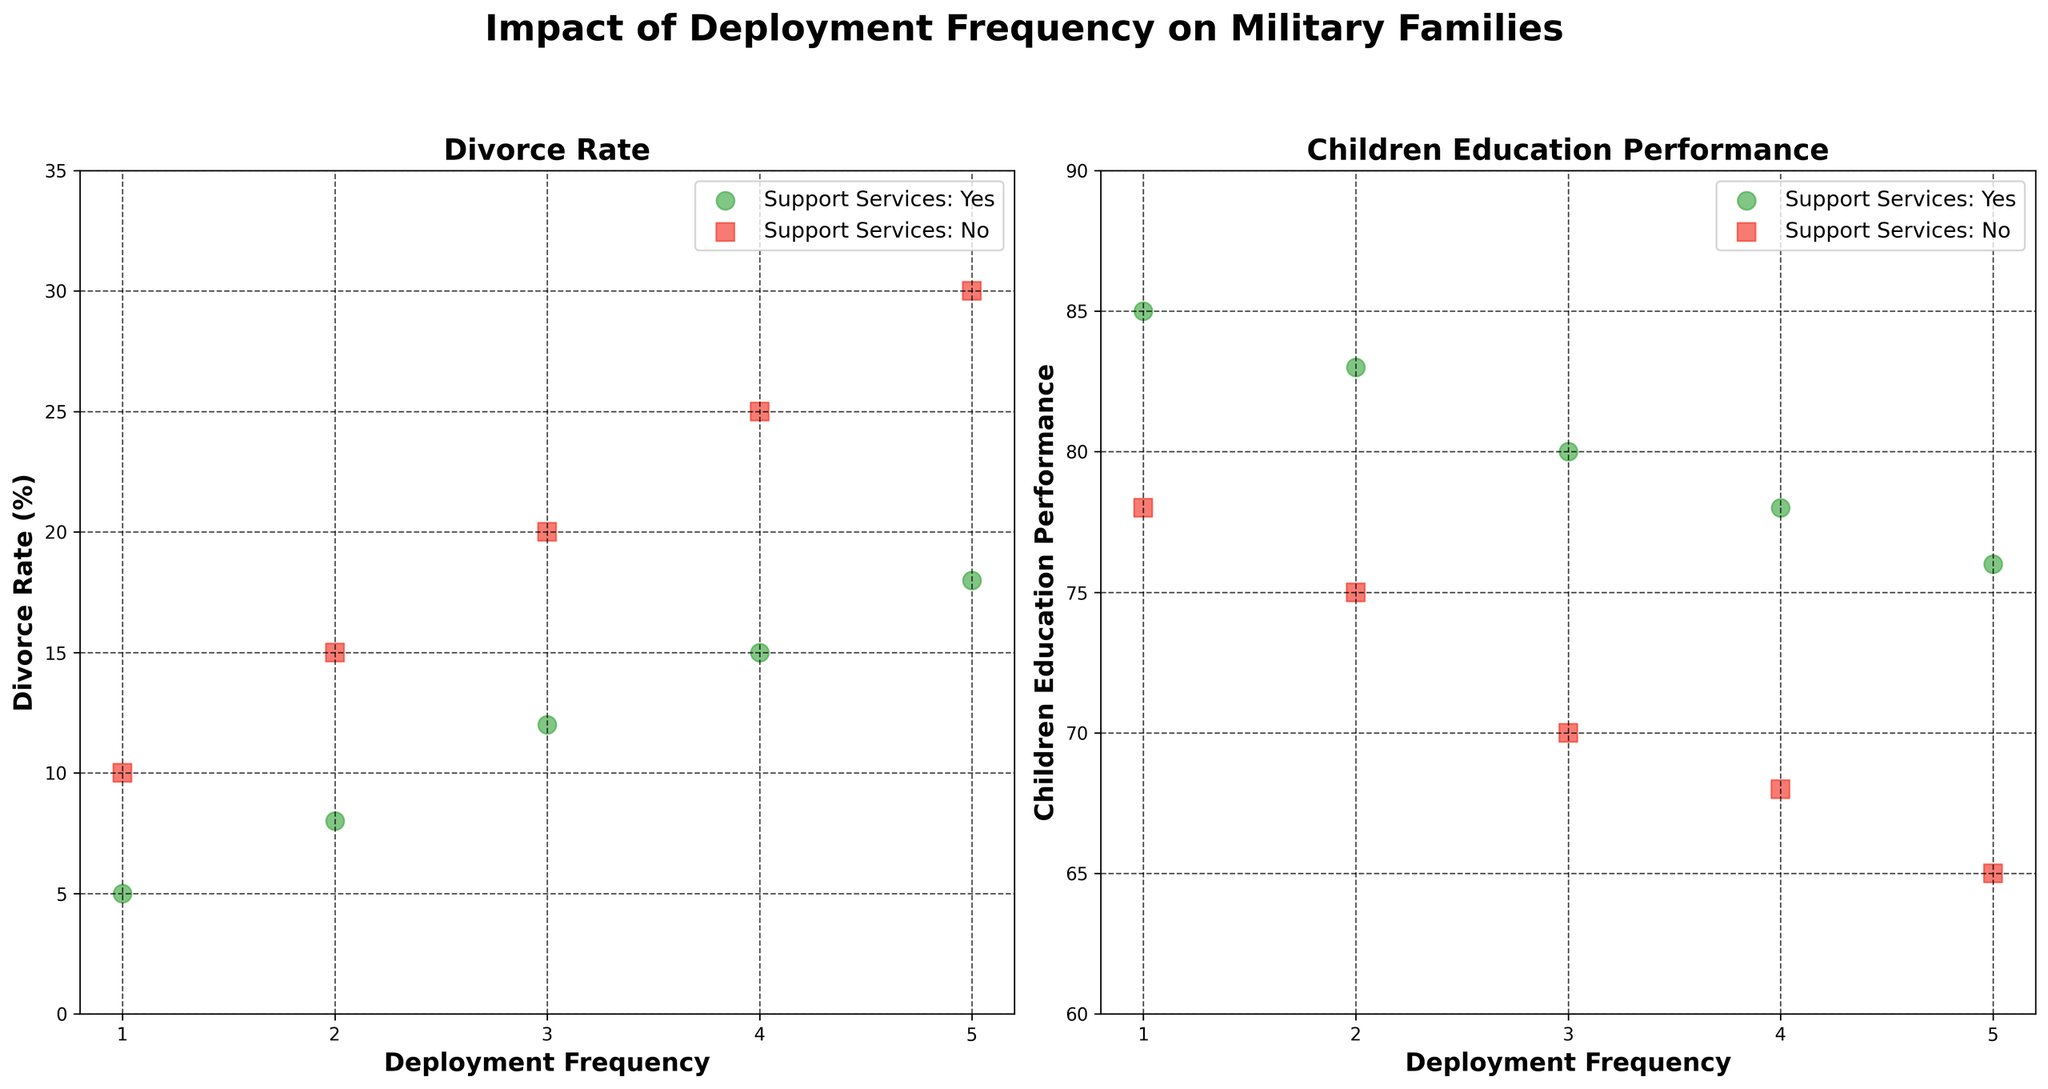What's the title of the figure? The title of the figure is centrally placed at the top in bold. It reads "Impact of Deployment Frequency on Military Families."
Answer: Impact of Deployment Frequency on Military Families What does the x-axis represent in both scatter plots? The x-axis represents deployment frequency, indicated by the label "Deployment Frequency" below both scatter plots.
Answer: Deployment Frequency What are the two different metrics measured in the y-axis of each scatter plot? The left scatter plot measures Divorce Rate (indicated by "Divorce Rate (%)" on the y-axis), while the right scatter plot measures Children's Education Performance (indicated by "Children Education Performance" on the y-axis).
Answer: Divorce Rate and Children's Education Performance What can you say about the marker shapes used in the scatter plots? The scatter plots use circles and squares to represent different groups. Circles ('o') represent "Support Services: Yes," and squares ('s') represent "Support Services: No."
Answer: Circles and squares represent Support Services Yes and No, respectively At deployment frequency 3, which group (Support Services Yes or No) has a higher divorce rate? At deployment frequency 3 on the left scatter plot, the green circle (Support Services Yes) is placed at 12%, whereas the red square (Support Services No) is placed at 20%. Thus, Support Services No has a higher divorce rate.
Answer: Support Services No Between deployment frequencies 1 and 2, is there any change in Children's Education Performance for the group receiving support services? For deployment frequency 1, the group receiving support services (green circle) scores 85, at frequency 2 they score 83. There is a slight decrease in the Children's Education Performance.
Answer: Decrease Which group appears to have a generally higher Children's Education Performance across all deployment frequencies? By comparing the positions of green circles and red squares on the right scatter plot, the green circles (Support Services Yes) are consistently higher than the red squares (Support Services No). Thus, the group with support services generally has higher Children's Education Performance.
Answer: Support Services Yes What is the approximate difference in Divorce Rate between the two support groups at deployment frequency 4? At deployment frequency 4, the Divorce Rate for Support Services Yes is approximately 15%, and for Support Services No it is roughly 25%. The difference is 25% - 15% = 10%.
Answer: 10% How does the Divorce Rate vary with increasing deployment frequency for the group not receiving support services? By observing the left scatter plot, the red squares (Support Services No) show a clear upward trend from 10% at frequency 1 to 30% at frequency 5, indicating an increase in Divorce Rate with higher deployment frequency.
Answer: Increases Do both scatter plots show a trend regarding the effect of deployment frequency on family impact? Please describe. Yes, both plots indicate trends. The left plot shows an increasing Divorce Rate with higher deployment frequencies, while the right plot depicts a decreasing Children's Education Performance with increasing deployment frequencies, especially for the less-supported group. Both trends are more pronounced for the group with no support services.
Answer: Yes, increasing Divorce Rate and decreasing Children's Education Performance 